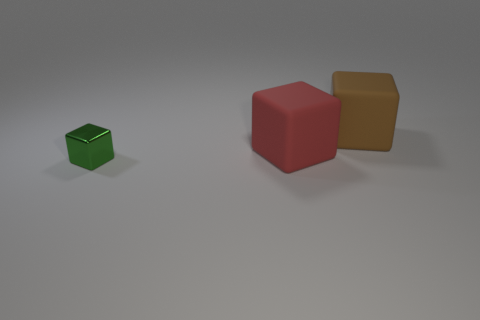What are the relative positions of the cubes to each other? The green cube is to the left and in front of the red cube, while the red cube is behind and to the left of the brown block when viewed from the camera's perspective.  Can you describe the lighting and shadows in the scene? The lighting in the scene is diffused, creating soft shadows that emerge to the lower right of each cube. This suggests a light source from the upper left side, outside the frame. The shadows are subtle, indicating that the light is not very harsh. 